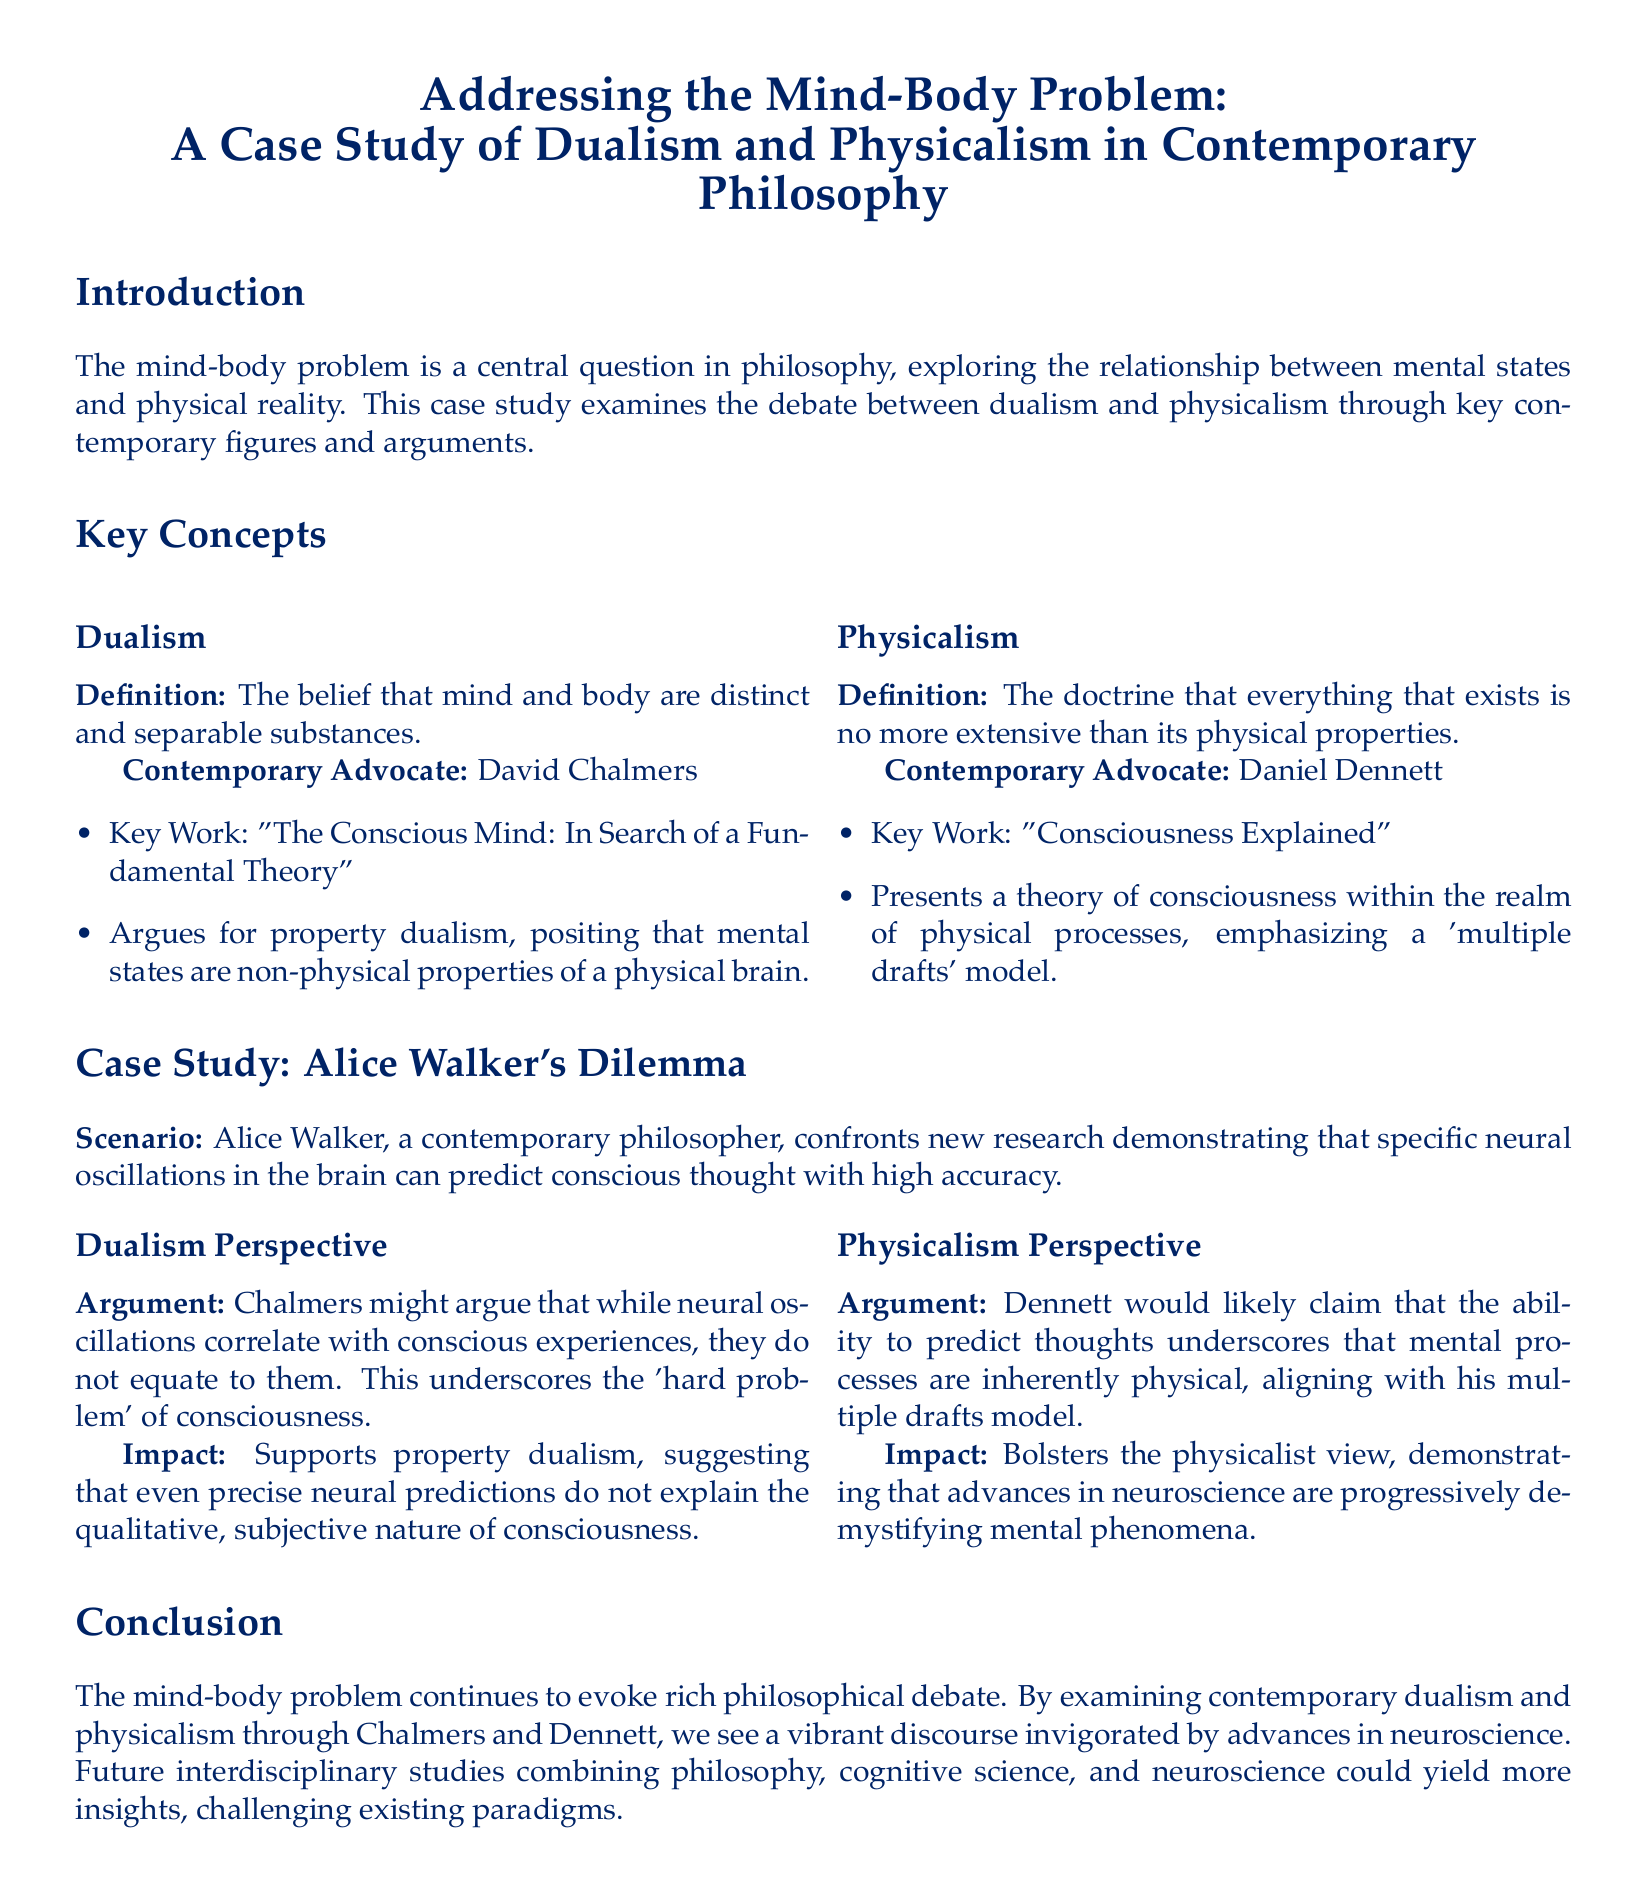what is the central question examined in the case study? The central question addressed in the case study is the mind-body problem, which explores the relationship between mental states and physical reality.
Answer: mind-body problem who is the contemporary advocate of dualism mentioned in the document? The document identifies David Chalmers as a contemporary advocate of dualism.
Answer: David Chalmers what is the key work of Daniel Dennett? The key work of Daniel Dennett as stated in the document is "Consciousness Explained."
Answer: Consciousness Explained what dilemma does Alice Walker confront in the case study? Alice Walker confronts new research demonstrating that specific neural oscillations in the brain can predict conscious thought with high accuracy.
Answer: specific neural oscillations which argument supports property dualism in the document? The argument supporting property dualism is that while neural oscillations correlate with conscious experiences, they do not equate to them, highlighting the 'hard problem' of consciousness.
Answer: 'hard problem' of consciousness what does Dennett's multiple drafts model emphasize? Dennett's multiple drafts model emphasizes that mental processes are inherently physical.
Answer: inherently physical what is one potential outcome of future interdisciplinary studies mentioned in the conclusion? One potential outcome suggested is that interdisciplinary studies could yield more insights challenging existing paradigms.
Answer: yield more insights who argues for property dualism? The document states that David Chalmers argues for property dualism.
Answer: David Chalmers how many perspectives are analyzed in Alice Walker's dilemma? The case study analyzes two perspectives—dualism and physicalism—regarding Alice Walker's dilemma.
Answer: two perspectives 